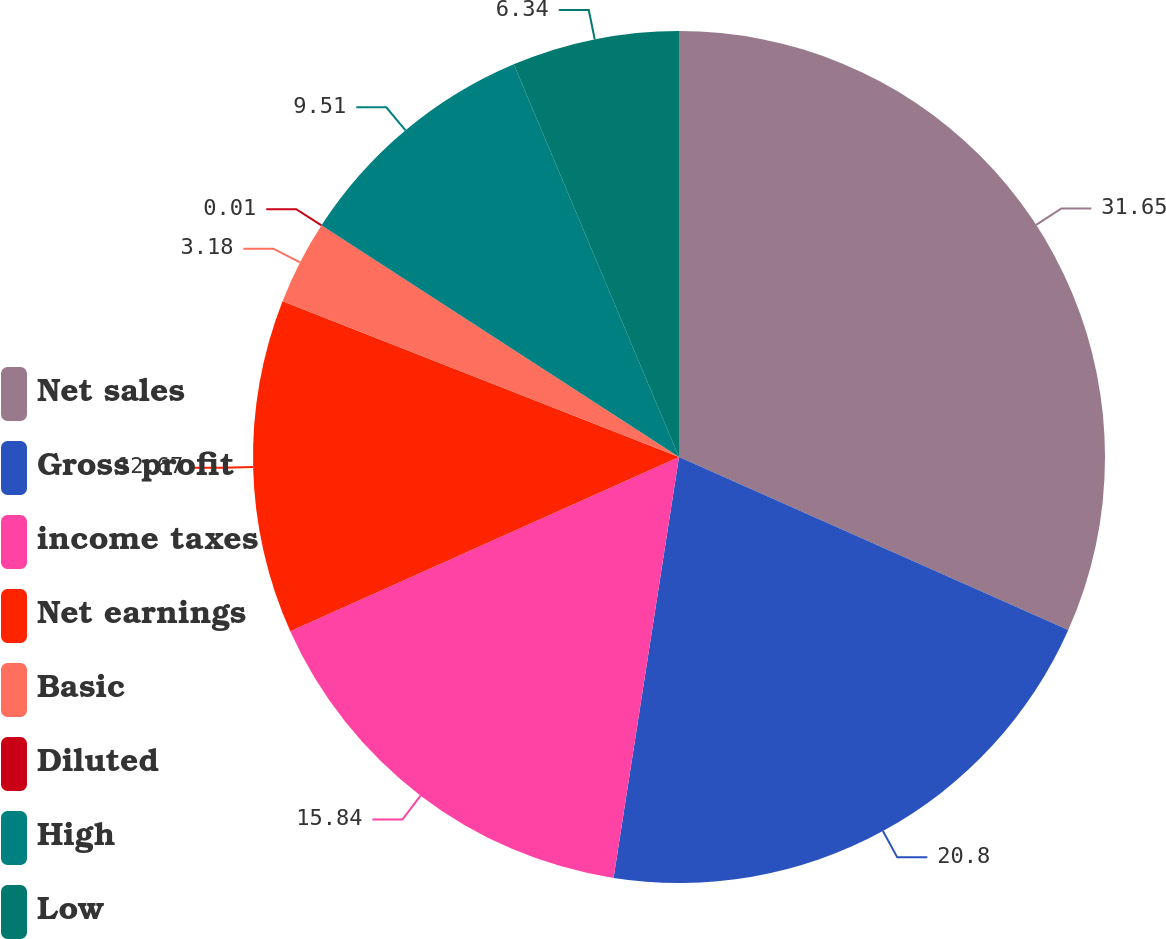Convert chart to OTSL. <chart><loc_0><loc_0><loc_500><loc_500><pie_chart><fcel>Net sales<fcel>Gross profit<fcel>income taxes<fcel>Net earnings<fcel>Basic<fcel>Diluted<fcel>High<fcel>Low<nl><fcel>31.66%<fcel>20.8%<fcel>15.84%<fcel>12.67%<fcel>3.18%<fcel>0.01%<fcel>9.51%<fcel>6.34%<nl></chart> 